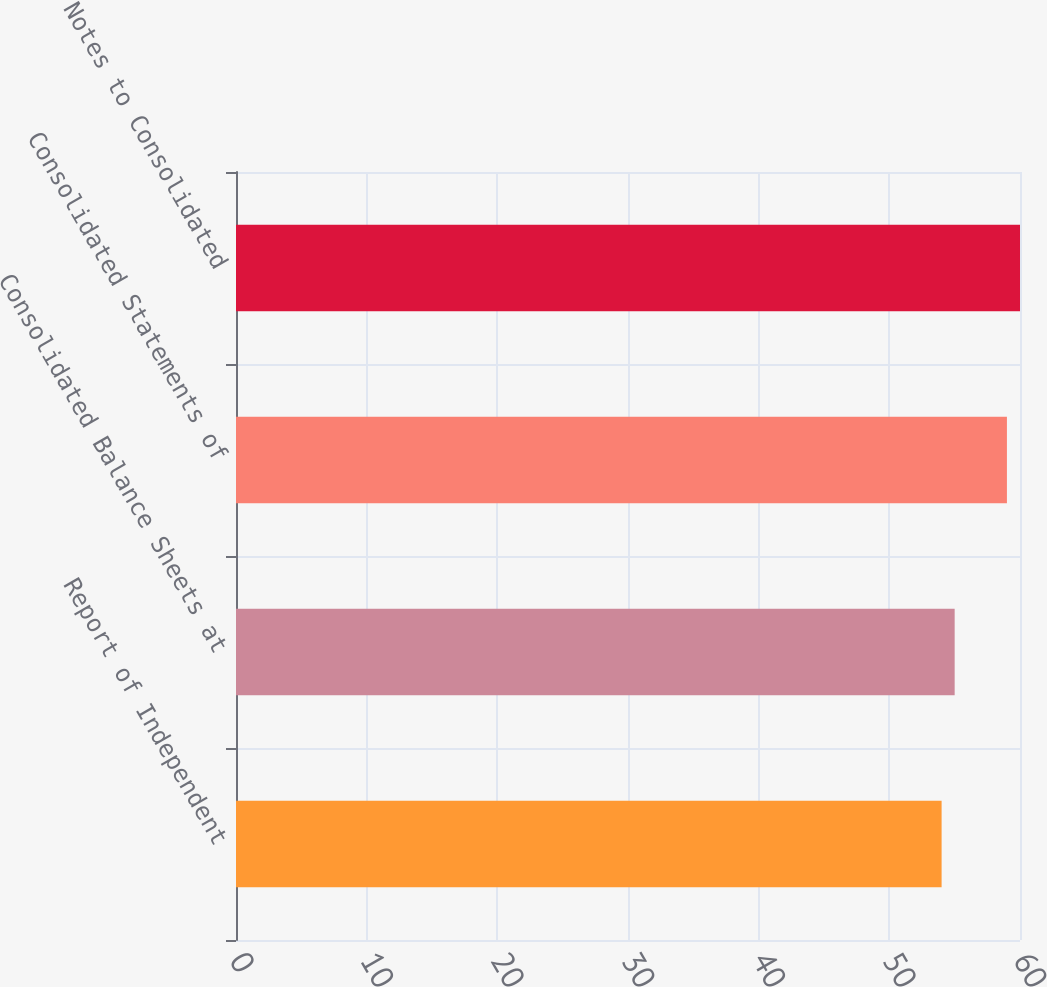Convert chart to OTSL. <chart><loc_0><loc_0><loc_500><loc_500><bar_chart><fcel>Report of Independent<fcel>Consolidated Balance Sheets at<fcel>Consolidated Statements of<fcel>Notes to Consolidated<nl><fcel>54<fcel>55<fcel>59<fcel>60<nl></chart> 